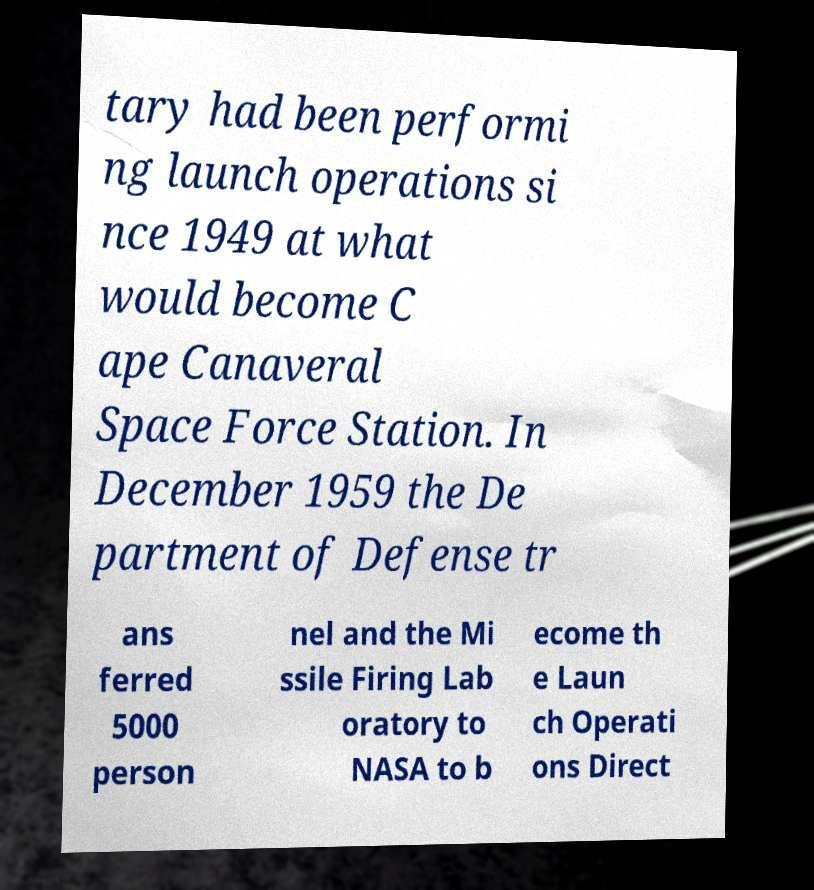Could you assist in decoding the text presented in this image and type it out clearly? tary had been performi ng launch operations si nce 1949 at what would become C ape Canaveral Space Force Station. In December 1959 the De partment of Defense tr ans ferred 5000 person nel and the Mi ssile Firing Lab oratory to NASA to b ecome th e Laun ch Operati ons Direct 